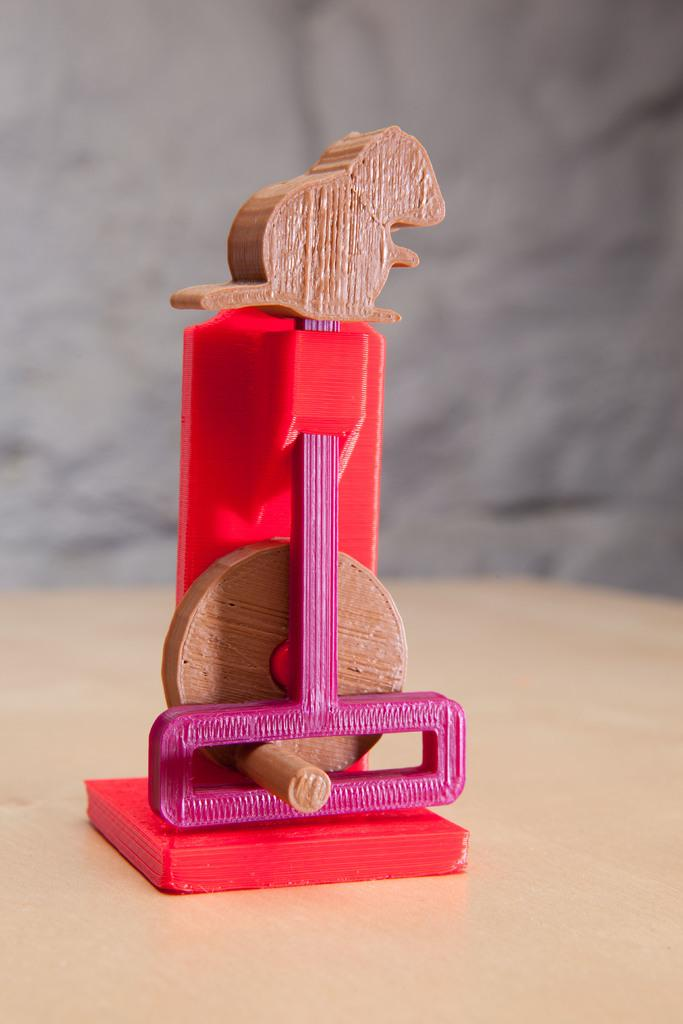What is the main subject of the image? The main subject of the image is a wooden object in the shape of a rat at the top of the image. How many cemeteries can be seen in the background of the image? There are no cemeteries present in the image; it only features a wooden rat. What type of bird is sitting on the wooden rat in the image? There is no bird, such as a crow, present in the image; it only features a wooden rat. 